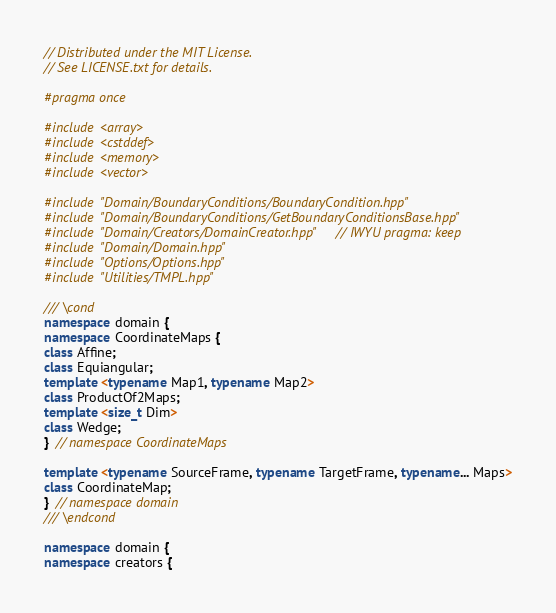<code> <loc_0><loc_0><loc_500><loc_500><_C++_>// Distributed under the MIT License.
// See LICENSE.txt for details.

#pragma once

#include <array>
#include <cstddef>
#include <memory>
#include <vector>

#include "Domain/BoundaryConditions/BoundaryCondition.hpp"
#include "Domain/BoundaryConditions/GetBoundaryConditionsBase.hpp"
#include "Domain/Creators/DomainCreator.hpp"  // IWYU pragma: keep
#include "Domain/Domain.hpp"
#include "Options/Options.hpp"
#include "Utilities/TMPL.hpp"

/// \cond
namespace domain {
namespace CoordinateMaps {
class Affine;
class Equiangular;
template <typename Map1, typename Map2>
class ProductOf2Maps;
template <size_t Dim>
class Wedge;
}  // namespace CoordinateMaps

template <typename SourceFrame, typename TargetFrame, typename... Maps>
class CoordinateMap;
}  // namespace domain
/// \endcond

namespace domain {
namespace creators {</code> 